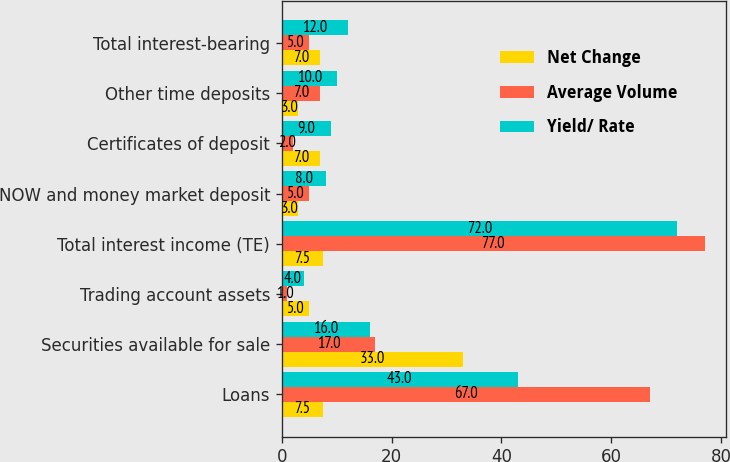Convert chart. <chart><loc_0><loc_0><loc_500><loc_500><stacked_bar_chart><ecel><fcel>Loans<fcel>Securities available for sale<fcel>Trading account assets<fcel>Total interest income (TE)<fcel>NOW and money market deposit<fcel>Certificates of deposit<fcel>Other time deposits<fcel>Total interest-bearing<nl><fcel>Net Change<fcel>7.5<fcel>33<fcel>5<fcel>7.5<fcel>3<fcel>7<fcel>3<fcel>7<nl><fcel>Average Volume<fcel>67<fcel>17<fcel>1<fcel>77<fcel>5<fcel>2<fcel>7<fcel>5<nl><fcel>Yield/ Rate<fcel>43<fcel>16<fcel>4<fcel>72<fcel>8<fcel>9<fcel>10<fcel>12<nl></chart> 